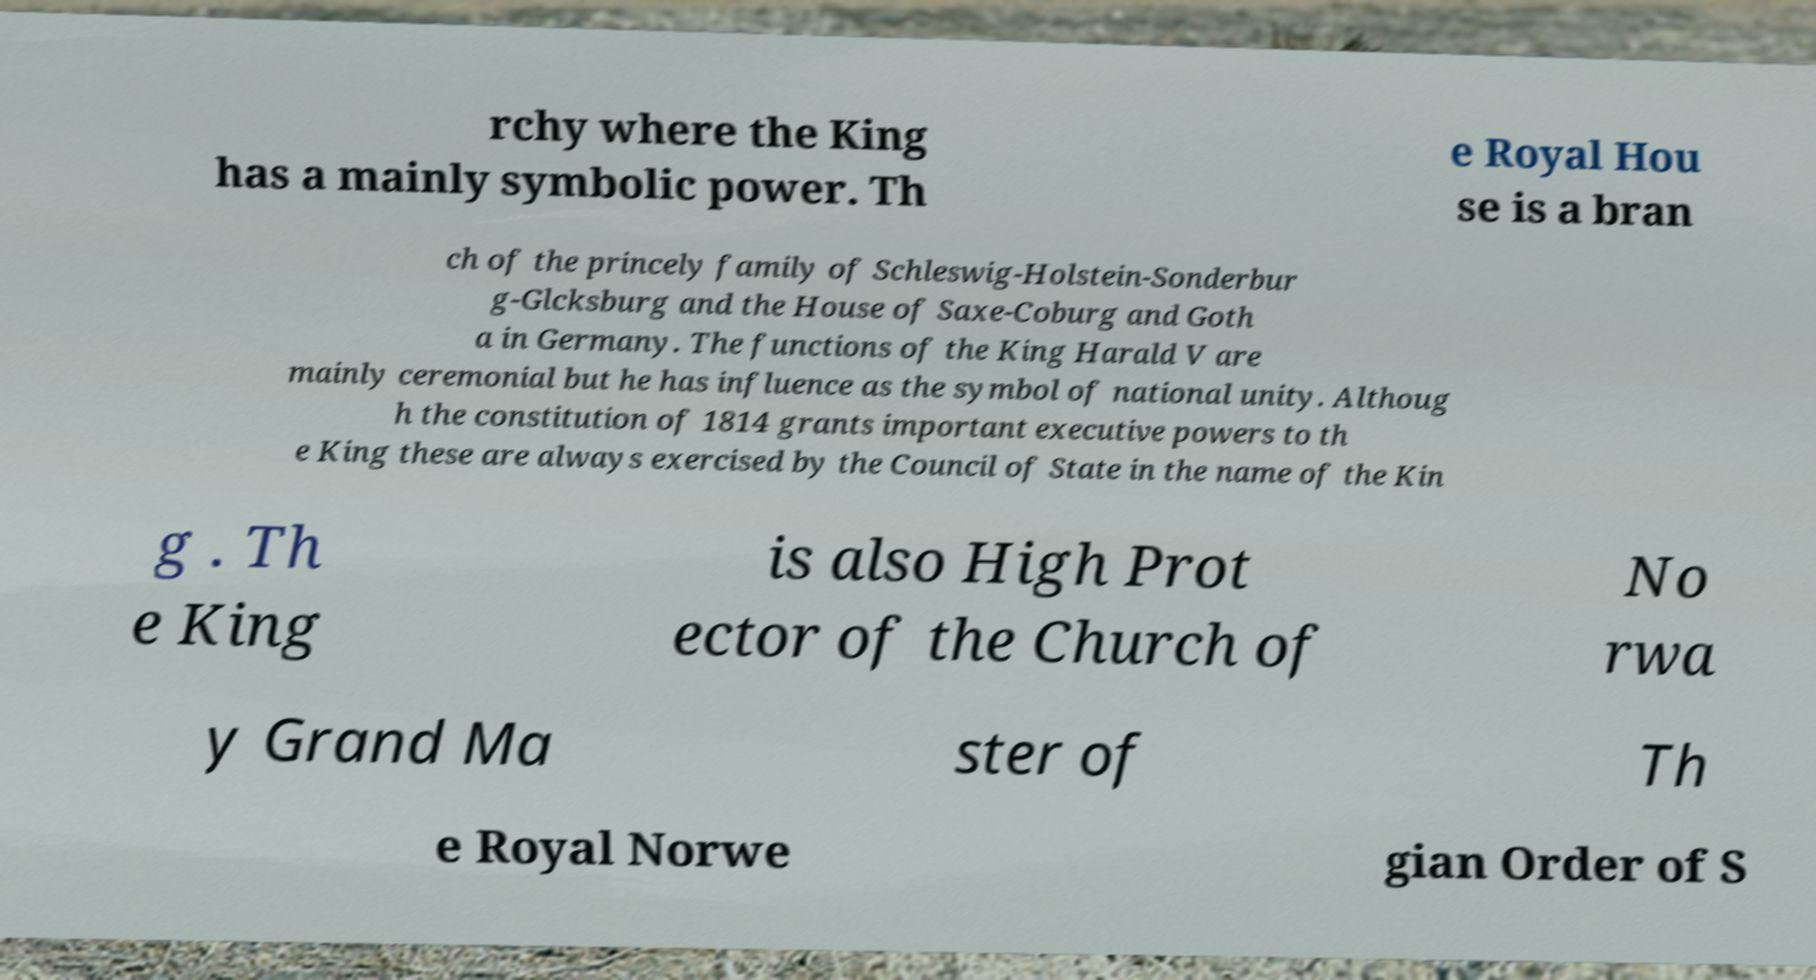What messages or text are displayed in this image? I need them in a readable, typed format. rchy where the King has a mainly symbolic power. Th e Royal Hou se is a bran ch of the princely family of Schleswig-Holstein-Sonderbur g-Glcksburg and the House of Saxe-Coburg and Goth a in Germany. The functions of the King Harald V are mainly ceremonial but he has influence as the symbol of national unity. Althoug h the constitution of 1814 grants important executive powers to th e King these are always exercised by the Council of State in the name of the Kin g . Th e King is also High Prot ector of the Church of No rwa y Grand Ma ster of Th e Royal Norwe gian Order of S 